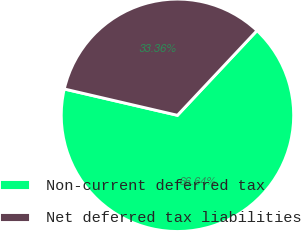<chart> <loc_0><loc_0><loc_500><loc_500><pie_chart><fcel>Non-current deferred tax<fcel>Net deferred tax liabilities<nl><fcel>66.64%<fcel>33.36%<nl></chart> 